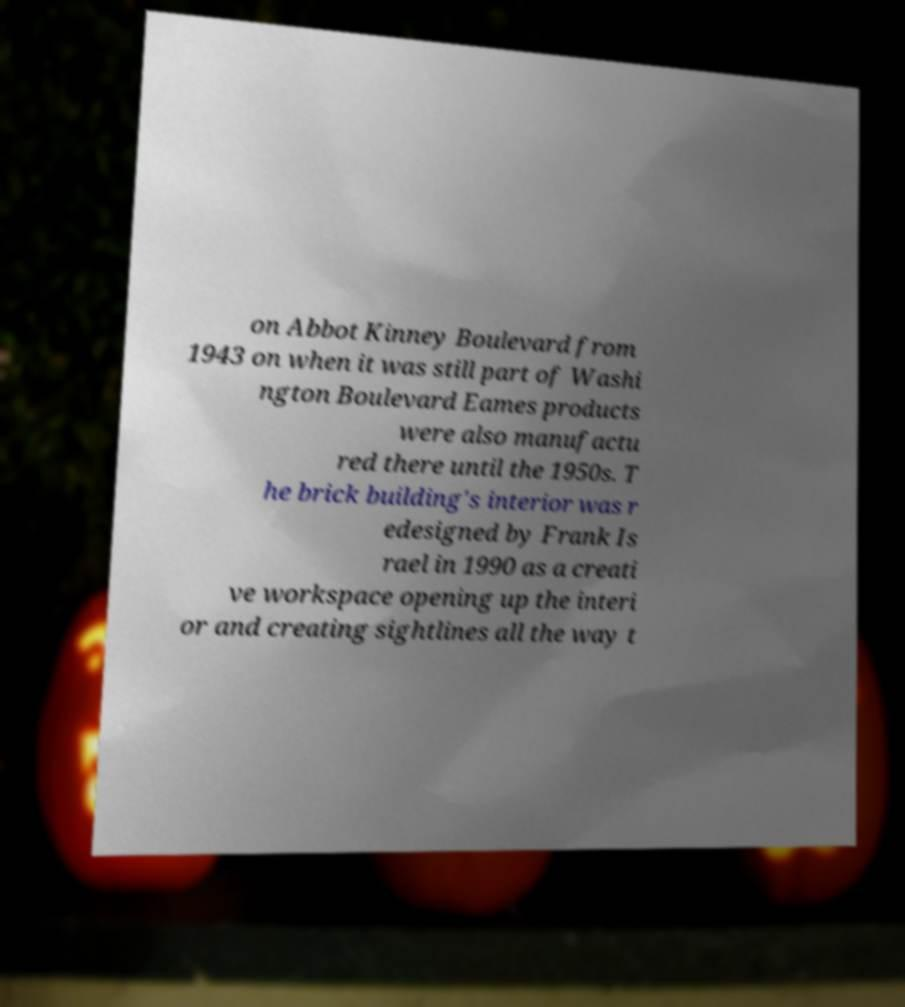There's text embedded in this image that I need extracted. Can you transcribe it verbatim? on Abbot Kinney Boulevard from 1943 on when it was still part of Washi ngton Boulevard Eames products were also manufactu red there until the 1950s. T he brick building's interior was r edesigned by Frank Is rael in 1990 as a creati ve workspace opening up the interi or and creating sightlines all the way t 